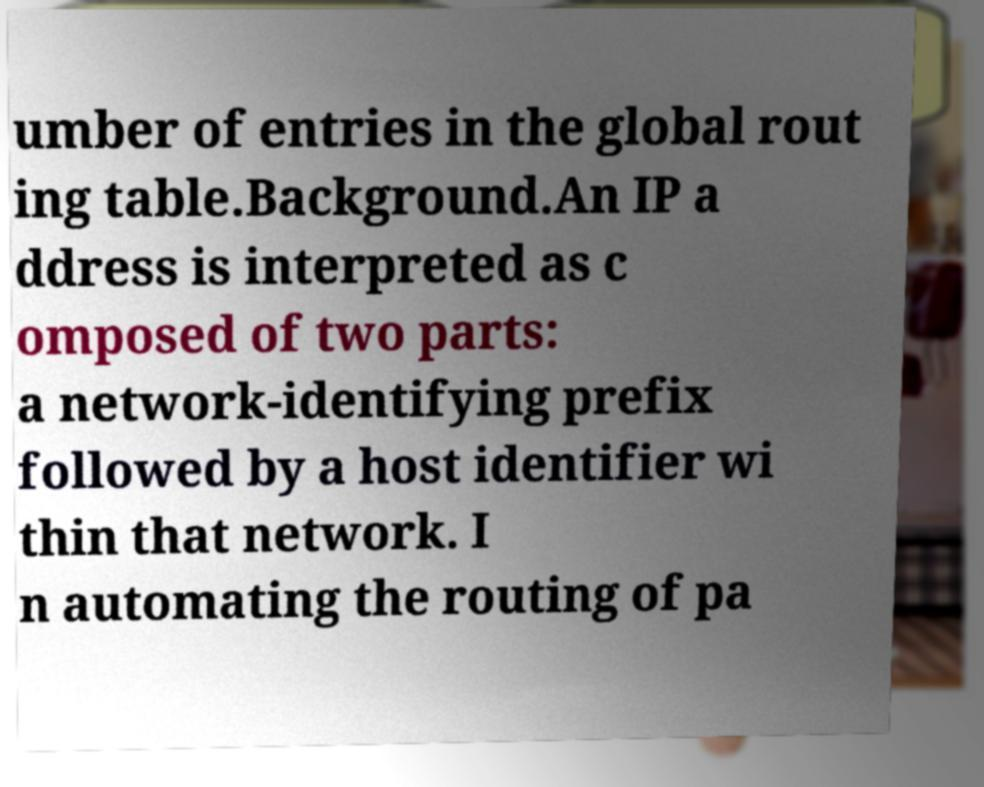What messages or text are displayed in this image? I need them in a readable, typed format. umber of entries in the global rout ing table.Background.An IP a ddress is interpreted as c omposed of two parts: a network-identifying prefix followed by a host identifier wi thin that network. I n automating the routing of pa 